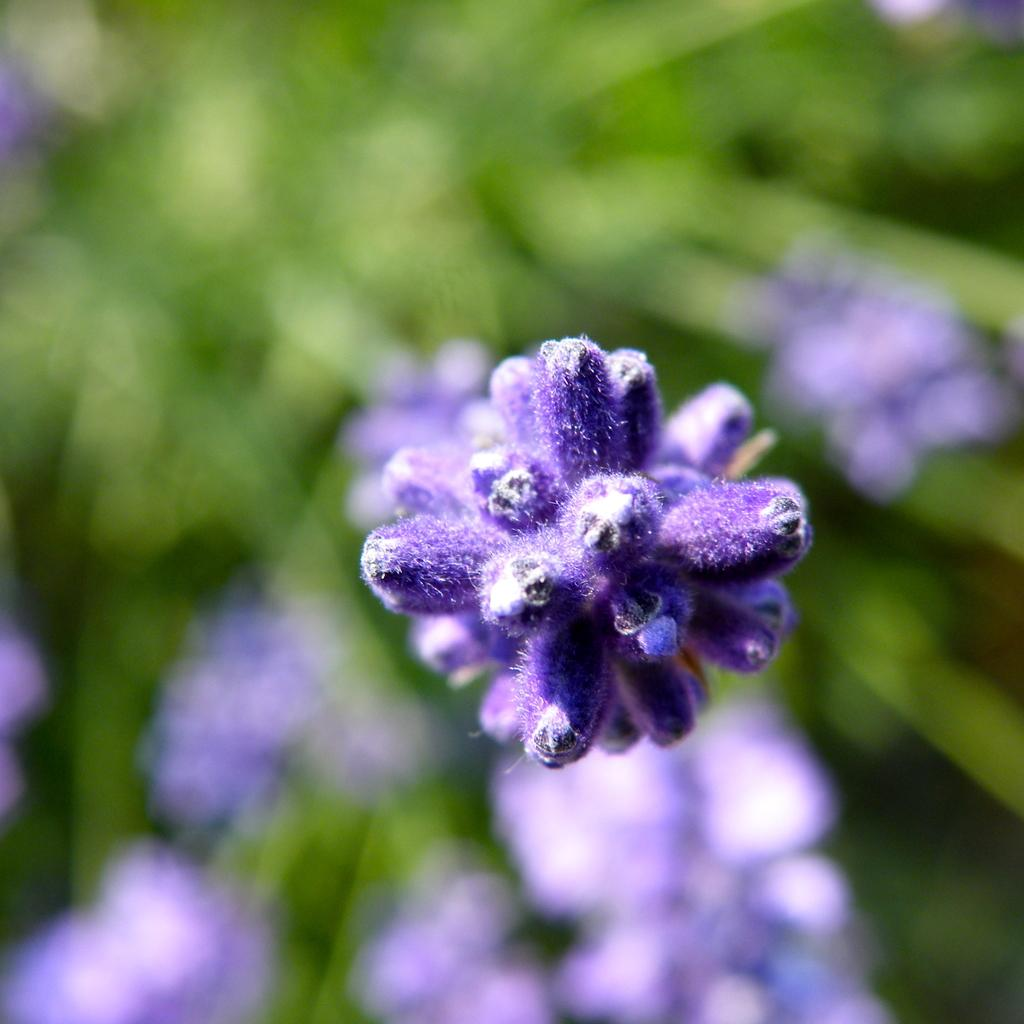What type of flora is present in the image? There are flowers in the image. What color are the flowers? The flowers are purple in color. Can you describe the background of the image? The background of the image is blurred. Can you see any bees interacting with the flowers in the image? There is no bee present in the image; it only features flowers. Are there any fangs visible on the flowers in the image? Flowers do not have fangs, so there are none visible in the image. 